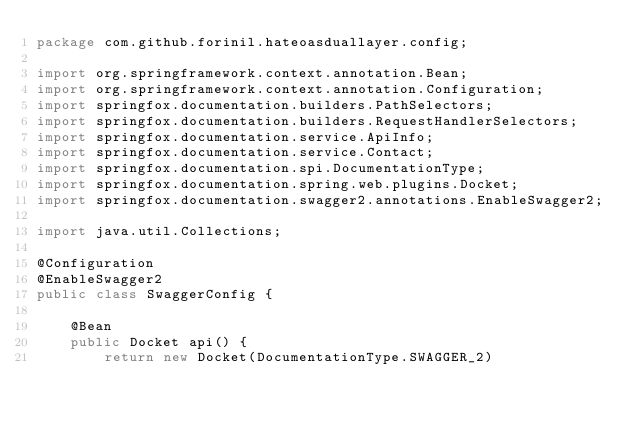<code> <loc_0><loc_0><loc_500><loc_500><_Java_>package com.github.forinil.hateoasduallayer.config;

import org.springframework.context.annotation.Bean;
import org.springframework.context.annotation.Configuration;
import springfox.documentation.builders.PathSelectors;
import springfox.documentation.builders.RequestHandlerSelectors;
import springfox.documentation.service.ApiInfo;
import springfox.documentation.service.Contact;
import springfox.documentation.spi.DocumentationType;
import springfox.documentation.spring.web.plugins.Docket;
import springfox.documentation.swagger2.annotations.EnableSwagger2;

import java.util.Collections;

@Configuration
@EnableSwagger2
public class SwaggerConfig {

    @Bean
    public Docket api() {
        return new Docket(DocumentationType.SWAGGER_2)</code> 